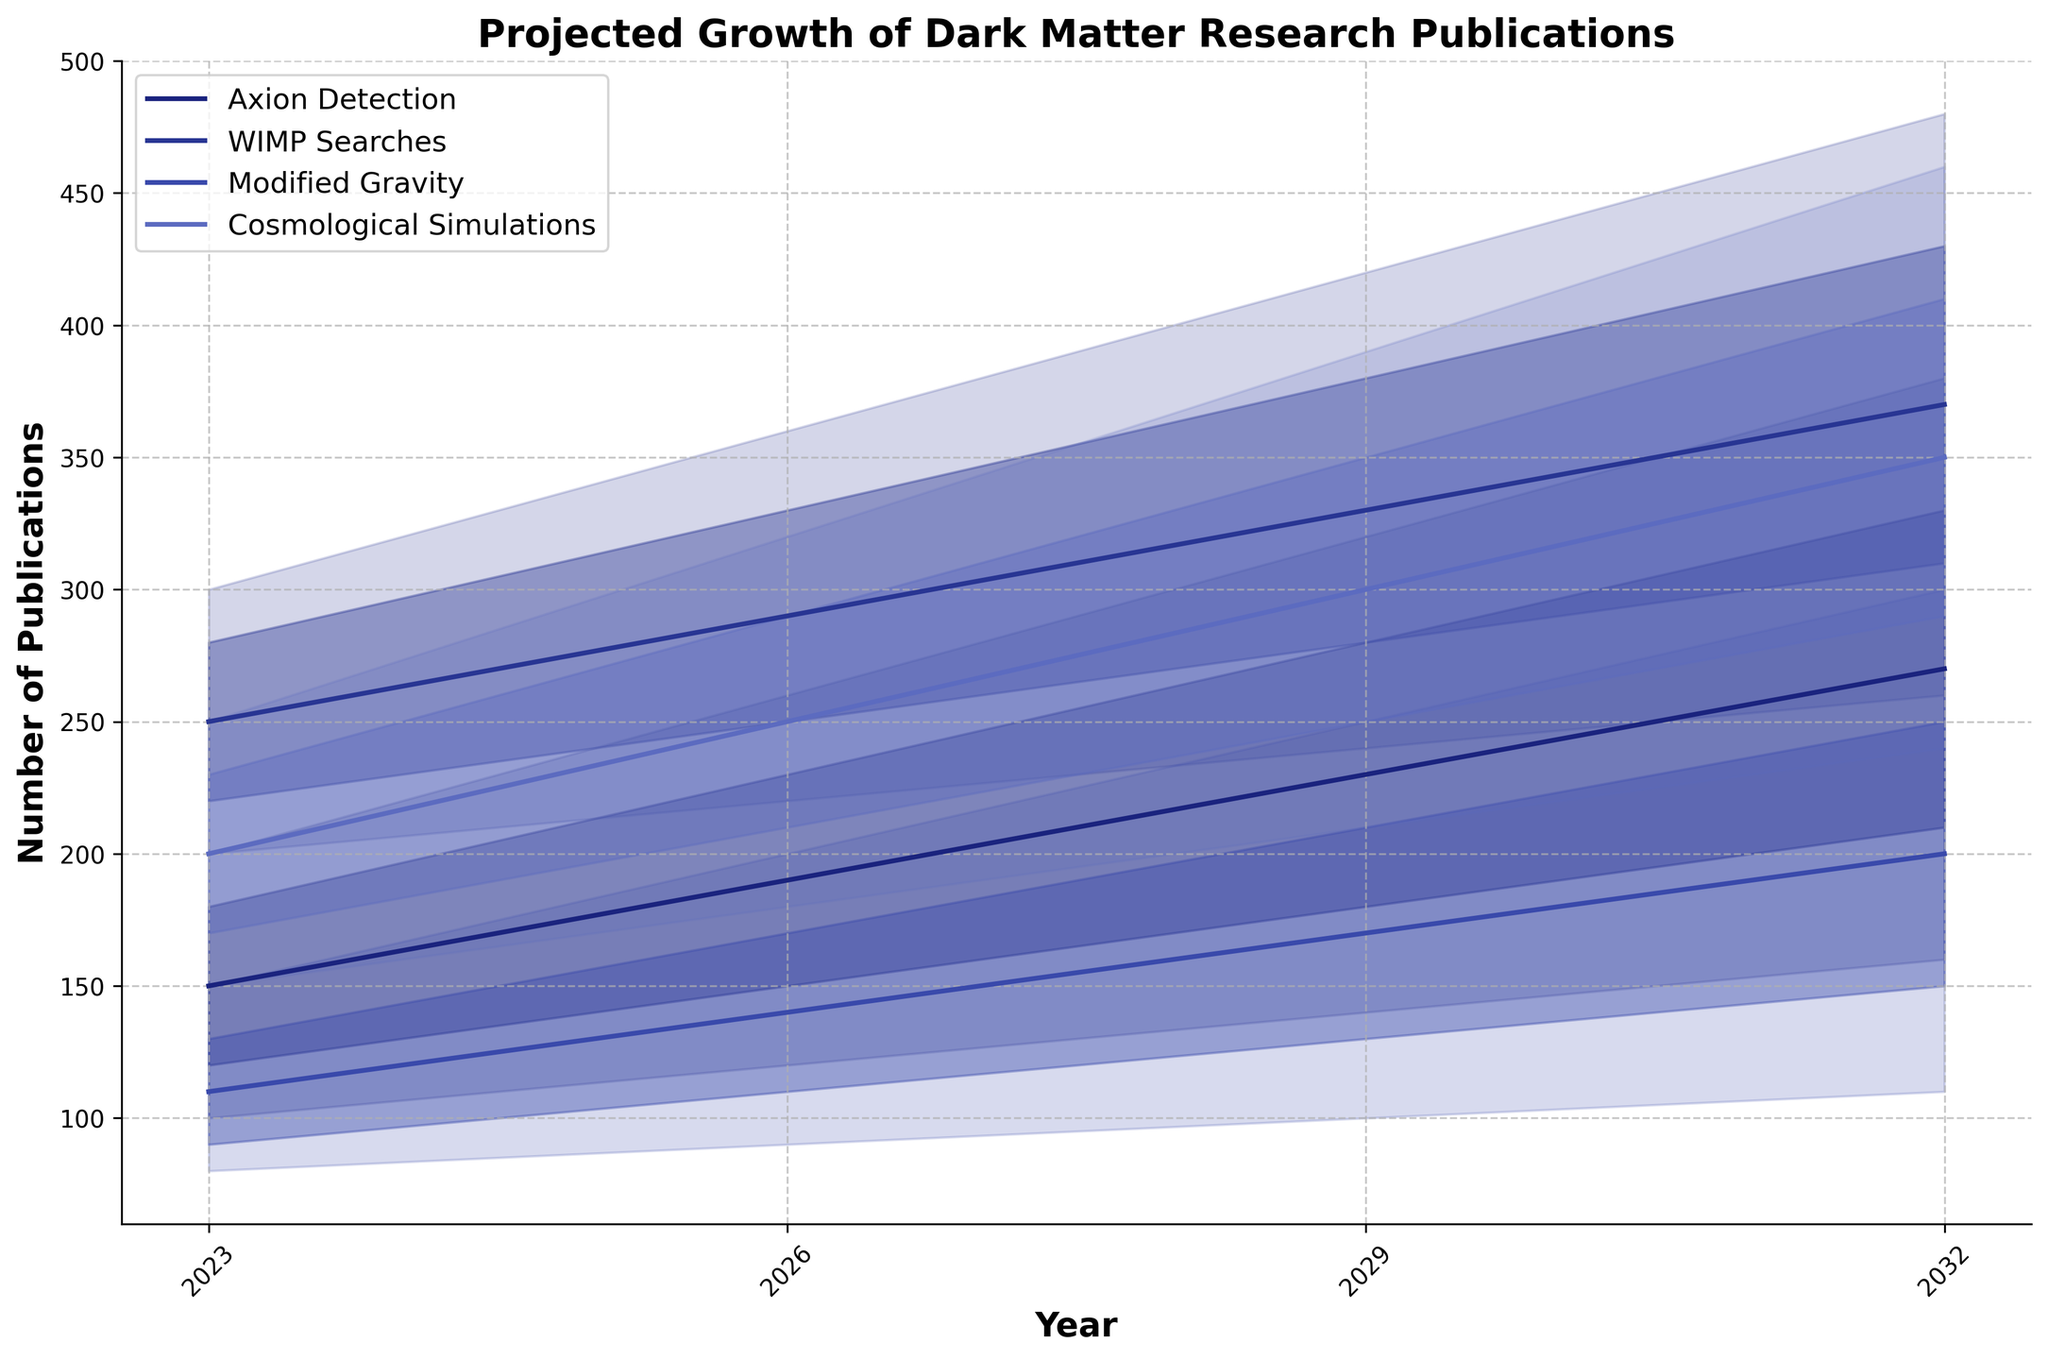What is the title of the plot? The title is typically centered at the top of the plot and is written in larger and bold text. In this case, it reads 'Projected Growth of Dark Matter Research Publications'.
Answer: Projected Growth of Dark Matter Research Publications Which subfield is expected to have the highest median number of publications in 2032? Look at the median projections for each subfield in 2032. The highest value under 'Median' for 2032 is associated with 'WIMP Searches' at 370 publications.
Answer: WIMP Searches What is the lower 10% bound for 'Modified Gravity' publications in 2026? The lower 10% bound for 'Modified Gravity' publications is found under the 'Lower_10' column for the year 2026. The value listed is 90.
Answer: 90 How many subfields are tracked in the plot? Count the unique subfields listed in the data, which are featured in the plot legend. The subfields are 'Axion Detection', 'WIMP Searches', 'Modified Gravity', and 'Cosmological Simulations'. This totals to 4 subfields.
Answer: 4 Between 2023 and 2032, how much is the median number of publications expected to increase for Axion Detection? Compare the median values for 'Axion Detection' in 2023 and 2032. In 2023, it is 150; in 2032, it is 270. The increase is 270 - 150 = 120.
Answer: 120 Which subfield has the narrowest prediction interval (difference between lower 10% and upper 90%) in 2023? Calculate the prediction interval for each subfield in 2023 by subtracting the 'Lower_10' value from the 'Upper_90' value. The results are:
- Axion Detection: 200 - 100 = 100
- WIMP Searches: 300 - 200 = 100
- Modified Gravity: 150 - 80 = 70
- Cosmological Simulations: 250 - 150 = 100
The narrowest interval is for 'Modified Gravity' at 70.
Answer: Modified Gravity How does the median projection for 'Cosmological Simulations' in 2026 compare to 'Axion Detection' in 2029? Refer to the median values for 'Cosmological Simulations' in 2026 and 'Axion Detection' in 2029. They are 250 and 230, respectively. So, 'Cosmological Simulations' in 2026 is higher (250 > 230).
Answer: Higher What is the projection trend of WIMP Searches' publications from 2023 to 2032? Observe the median line for 'WIMP Searches' from 2023 to 2032. It consistently increases from 250 in 2023 to 370 in 2032. This indicates an upward trend.
Answer: Upward trend Which subfield has the highest upper 90% bound in any year, according to the data? Identify the highest value in the 'Upper_90' column across all years and subfields. The highest value is 480 for 'WIMP Searches' in the year 2032.
Answer: WIMP Searches What is the general shape of the prediction intervals for all subfields over the decade? Observe the shaded regions representing the prediction intervals between 10% and 90% bounds. These typically widen over time, indicating increasing uncertainty about future publication counts.
Answer: Widening over time 